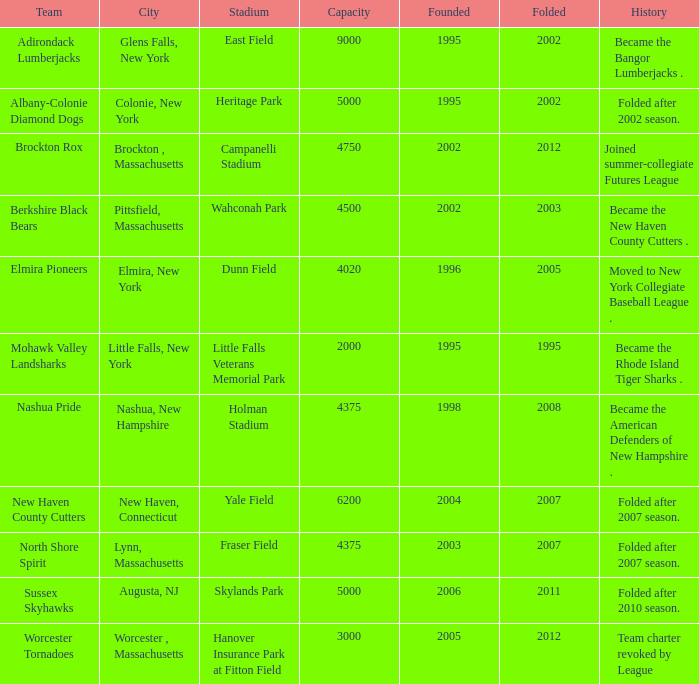Help me parse the entirety of this table. {'header': ['Team', 'City', 'Stadium', 'Capacity', 'Founded', 'Folded', 'History'], 'rows': [['Adirondack Lumberjacks', 'Glens Falls, New York', 'East Field', '9000', '1995', '2002', 'Became the Bangor Lumberjacks .'], ['Albany-Colonie Diamond Dogs', 'Colonie, New York', 'Heritage Park', '5000', '1995', '2002', 'Folded after 2002 season.'], ['Brockton Rox', 'Brockton , Massachusetts', 'Campanelli Stadium', '4750', '2002', '2012', 'Joined summer-collegiate Futures League'], ['Berkshire Black Bears', 'Pittsfield, Massachusetts', 'Wahconah Park', '4500', '2002', '2003', 'Became the New Haven County Cutters .'], ['Elmira Pioneers', 'Elmira, New York', 'Dunn Field', '4020', '1996', '2005', 'Moved to New York Collegiate Baseball League .'], ['Mohawk Valley Landsharks', 'Little Falls, New York', 'Little Falls Veterans Memorial Park', '2000', '1995', '1995', 'Became the Rhode Island Tiger Sharks .'], ['Nashua Pride', 'Nashua, New Hampshire', 'Holman Stadium', '4375', '1998', '2008', 'Became the American Defenders of New Hampshire .'], ['New Haven County Cutters', 'New Haven, Connecticut', 'Yale Field', '6200', '2004', '2007', 'Folded after 2007 season.'], ['North Shore Spirit', 'Lynn, Massachusetts', 'Fraser Field', '4375', '2003', '2007', 'Folded after 2007 season.'], ['Sussex Skyhawks', 'Augusta, NJ', 'Skylands Park', '5000', '2006', '2011', 'Folded after 2010 season.'], ['Worcester Tornadoes', 'Worcester , Massachusetts', 'Hanover Insurance Park at Fitton Field', '3000', '2005', '2012', 'Team charter revoked by League']]} What is the greatest folded value of the team whose arena is fraser field? 2007.0. 